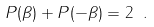Convert formula to latex. <formula><loc_0><loc_0><loc_500><loc_500>P ( \beta ) + P ( - \beta ) = 2 \ .</formula> 